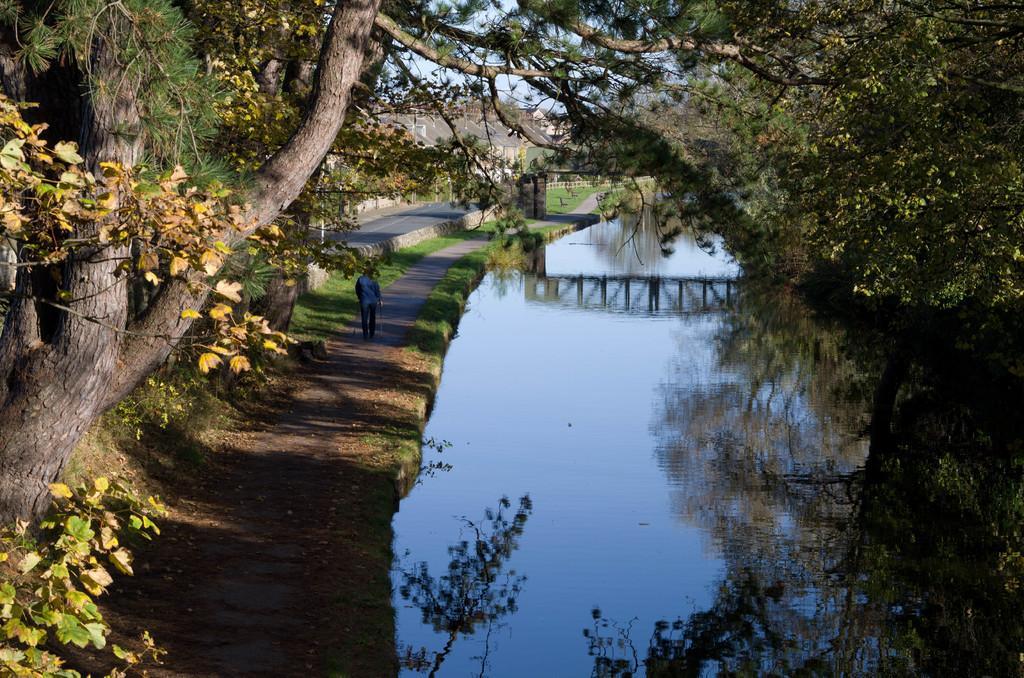Could you give a brief overview of what you see in this image? This image consists of water. On the left, there is a person walking. On the left and right, we can see the trees. In the background, there are houses. 